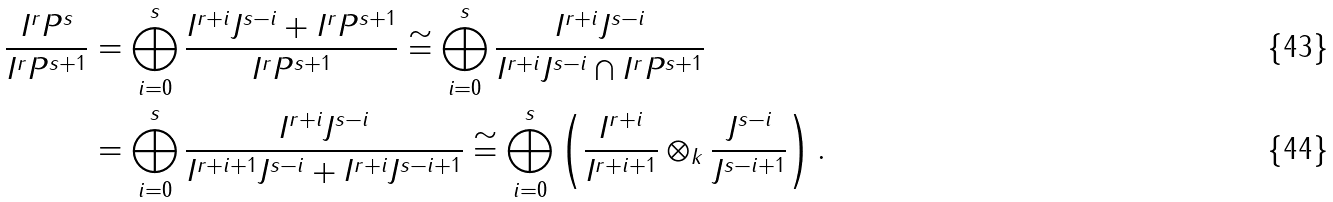Convert formula to latex. <formula><loc_0><loc_0><loc_500><loc_500>\frac { I ^ { r } P ^ { s } } { I ^ { r } P ^ { s + 1 } } & = \bigoplus _ { i = 0 } ^ { s } \frac { I ^ { r + i } J ^ { s - i } + I ^ { r } P ^ { s + 1 } } { I ^ { r } P ^ { s + 1 } } \cong \bigoplus _ { i = 0 } ^ { s } \frac { I ^ { r + i } J ^ { s - i } } { I ^ { r + i } J ^ { s - i } \cap I ^ { r } P ^ { s + 1 } } \\ & = \bigoplus _ { i = 0 } ^ { s } \frac { I ^ { r + i } J ^ { s - i } } { I ^ { r + i + 1 } J ^ { s - i } + I ^ { r + i } J ^ { s - i + 1 } } \cong \bigoplus _ { i = 0 } ^ { s } \left ( \frac { I ^ { r + i } } { I ^ { r + i + 1 } } \otimes _ { k } \frac { J ^ { s - i } } { J ^ { s - i + 1 } } \right ) .</formula> 